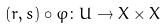Convert formula to latex. <formula><loc_0><loc_0><loc_500><loc_500>( r , s ) \circ \varphi \colon U \rightarrow X \times X</formula> 